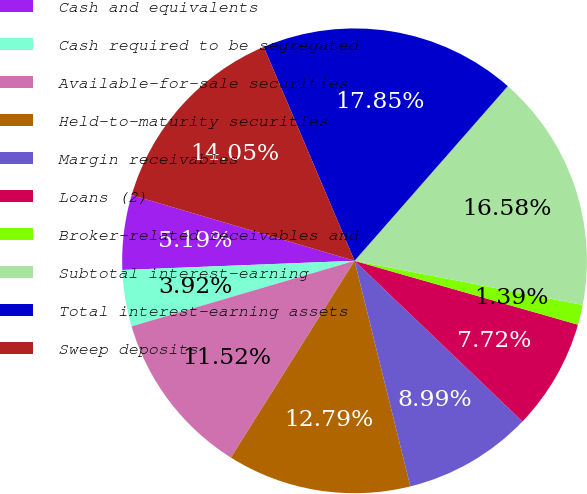Convert chart to OTSL. <chart><loc_0><loc_0><loc_500><loc_500><pie_chart><fcel>Cash and equivalents<fcel>Cash required to be segregated<fcel>Available-for-sale securities<fcel>Held-to-maturity securities<fcel>Margin receivables<fcel>Loans (2)<fcel>Broker-related receivables and<fcel>Subtotal interest-earning<fcel>Total interest-earning assets<fcel>Sweep deposits<nl><fcel>5.19%<fcel>3.92%<fcel>11.52%<fcel>12.79%<fcel>8.99%<fcel>7.72%<fcel>1.39%<fcel>16.58%<fcel>17.85%<fcel>14.05%<nl></chart> 